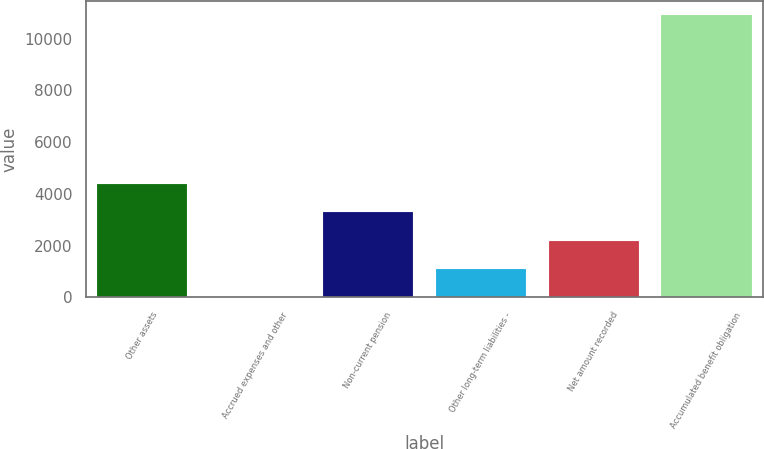Convert chart to OTSL. <chart><loc_0><loc_0><loc_500><loc_500><bar_chart><fcel>Other assets<fcel>Accrued expenses and other<fcel>Non-current pension<fcel>Other long-term liabilities -<fcel>Net amount recorded<fcel>Accumulated benefit obligation<nl><fcel>4369.2<fcel>20<fcel>3281.9<fcel>1107.3<fcel>2194.6<fcel>10893<nl></chart> 